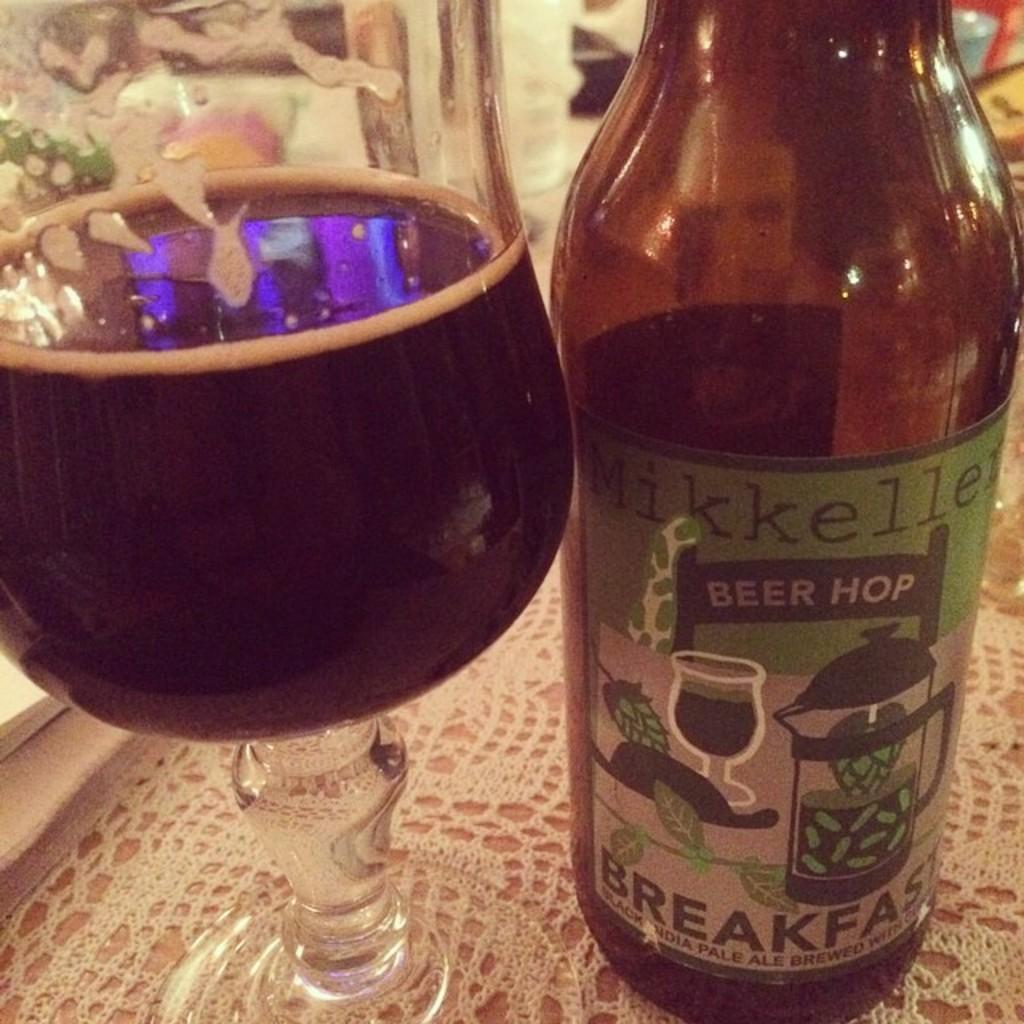What is on the table in the image? There is a glass and a bottle on the table in the image. Can you describe the glass and the bottle? The glass and the bottle are both objects that can hold liquids. What is the relationship between the glass and the bottle in the image? Both the glass and the bottle are on the table in the image. What type of rhythm does the insect create while walking on the glass in the image? There is no insect present in the image, so it cannot create any rhythm while walking on the glass. 